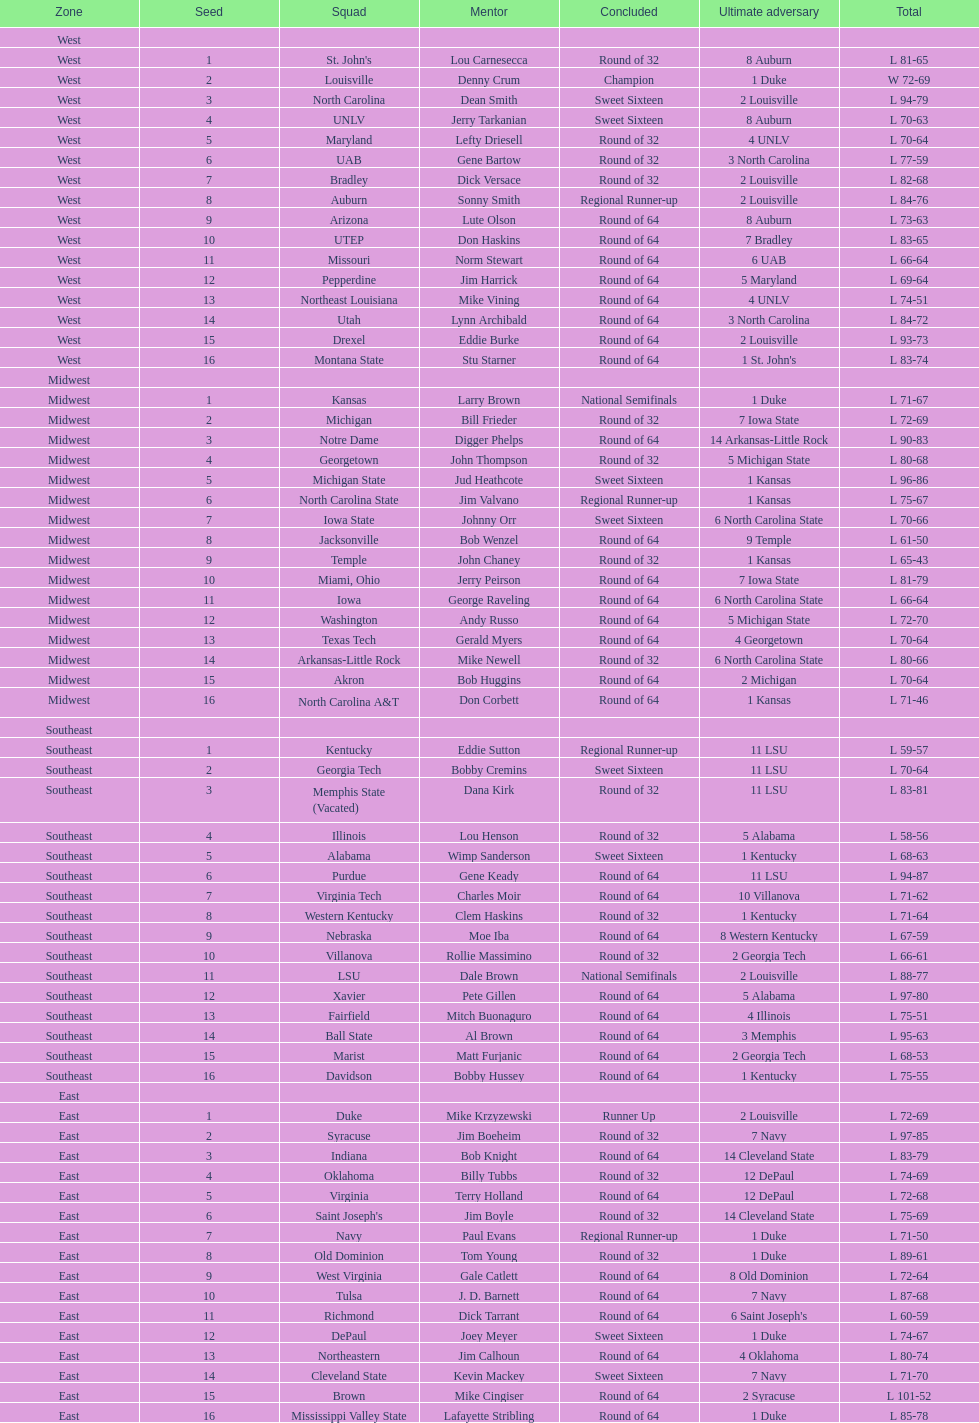Could you parse the entire table as a dict? {'header': ['Zone', 'Seed', 'Squad', 'Mentor', 'Concluded', 'Ultimate adversary', 'Total'], 'rows': [['West', '', '', '', '', '', ''], ['West', '1', "St. John's", 'Lou Carnesecca', 'Round of 32', '8 Auburn', 'L 81-65'], ['West', '2', 'Louisville', 'Denny Crum', 'Champion', '1 Duke', 'W 72-69'], ['West', '3', 'North Carolina', 'Dean Smith', 'Sweet Sixteen', '2 Louisville', 'L 94-79'], ['West', '4', 'UNLV', 'Jerry Tarkanian', 'Sweet Sixteen', '8 Auburn', 'L 70-63'], ['West', '5', 'Maryland', 'Lefty Driesell', 'Round of 32', '4 UNLV', 'L 70-64'], ['West', '6', 'UAB', 'Gene Bartow', 'Round of 32', '3 North Carolina', 'L 77-59'], ['West', '7', 'Bradley', 'Dick Versace', 'Round of 32', '2 Louisville', 'L 82-68'], ['West', '8', 'Auburn', 'Sonny Smith', 'Regional Runner-up', '2 Louisville', 'L 84-76'], ['West', '9', 'Arizona', 'Lute Olson', 'Round of 64', '8 Auburn', 'L 73-63'], ['West', '10', 'UTEP', 'Don Haskins', 'Round of 64', '7 Bradley', 'L 83-65'], ['West', '11', 'Missouri', 'Norm Stewart', 'Round of 64', '6 UAB', 'L 66-64'], ['West', '12', 'Pepperdine', 'Jim Harrick', 'Round of 64', '5 Maryland', 'L 69-64'], ['West', '13', 'Northeast Louisiana', 'Mike Vining', 'Round of 64', '4 UNLV', 'L 74-51'], ['West', '14', 'Utah', 'Lynn Archibald', 'Round of 64', '3 North Carolina', 'L 84-72'], ['West', '15', 'Drexel', 'Eddie Burke', 'Round of 64', '2 Louisville', 'L 93-73'], ['West', '16', 'Montana State', 'Stu Starner', 'Round of 64', "1 St. John's", 'L 83-74'], ['Midwest', '', '', '', '', '', ''], ['Midwest', '1', 'Kansas', 'Larry Brown', 'National Semifinals', '1 Duke', 'L 71-67'], ['Midwest', '2', 'Michigan', 'Bill Frieder', 'Round of 32', '7 Iowa State', 'L 72-69'], ['Midwest', '3', 'Notre Dame', 'Digger Phelps', 'Round of 64', '14 Arkansas-Little Rock', 'L 90-83'], ['Midwest', '4', 'Georgetown', 'John Thompson', 'Round of 32', '5 Michigan State', 'L 80-68'], ['Midwest', '5', 'Michigan State', 'Jud Heathcote', 'Sweet Sixteen', '1 Kansas', 'L 96-86'], ['Midwest', '6', 'North Carolina State', 'Jim Valvano', 'Regional Runner-up', '1 Kansas', 'L 75-67'], ['Midwest', '7', 'Iowa State', 'Johnny Orr', 'Sweet Sixteen', '6 North Carolina State', 'L 70-66'], ['Midwest', '8', 'Jacksonville', 'Bob Wenzel', 'Round of 64', '9 Temple', 'L 61-50'], ['Midwest', '9', 'Temple', 'John Chaney', 'Round of 32', '1 Kansas', 'L 65-43'], ['Midwest', '10', 'Miami, Ohio', 'Jerry Peirson', 'Round of 64', '7 Iowa State', 'L 81-79'], ['Midwest', '11', 'Iowa', 'George Raveling', 'Round of 64', '6 North Carolina State', 'L 66-64'], ['Midwest', '12', 'Washington', 'Andy Russo', 'Round of 64', '5 Michigan State', 'L 72-70'], ['Midwest', '13', 'Texas Tech', 'Gerald Myers', 'Round of 64', '4 Georgetown', 'L 70-64'], ['Midwest', '14', 'Arkansas-Little Rock', 'Mike Newell', 'Round of 32', '6 North Carolina State', 'L 80-66'], ['Midwest', '15', 'Akron', 'Bob Huggins', 'Round of 64', '2 Michigan', 'L 70-64'], ['Midwest', '16', 'North Carolina A&T', 'Don Corbett', 'Round of 64', '1 Kansas', 'L 71-46'], ['Southeast', '', '', '', '', '', ''], ['Southeast', '1', 'Kentucky', 'Eddie Sutton', 'Regional Runner-up', '11 LSU', 'L 59-57'], ['Southeast', '2', 'Georgia Tech', 'Bobby Cremins', 'Sweet Sixteen', '11 LSU', 'L 70-64'], ['Southeast', '3', 'Memphis State (Vacated)', 'Dana Kirk', 'Round of 32', '11 LSU', 'L 83-81'], ['Southeast', '4', 'Illinois', 'Lou Henson', 'Round of 32', '5 Alabama', 'L 58-56'], ['Southeast', '5', 'Alabama', 'Wimp Sanderson', 'Sweet Sixteen', '1 Kentucky', 'L 68-63'], ['Southeast', '6', 'Purdue', 'Gene Keady', 'Round of 64', '11 LSU', 'L 94-87'], ['Southeast', '7', 'Virginia Tech', 'Charles Moir', 'Round of 64', '10 Villanova', 'L 71-62'], ['Southeast', '8', 'Western Kentucky', 'Clem Haskins', 'Round of 32', '1 Kentucky', 'L 71-64'], ['Southeast', '9', 'Nebraska', 'Moe Iba', 'Round of 64', '8 Western Kentucky', 'L 67-59'], ['Southeast', '10', 'Villanova', 'Rollie Massimino', 'Round of 32', '2 Georgia Tech', 'L 66-61'], ['Southeast', '11', 'LSU', 'Dale Brown', 'National Semifinals', '2 Louisville', 'L 88-77'], ['Southeast', '12', 'Xavier', 'Pete Gillen', 'Round of 64', '5 Alabama', 'L 97-80'], ['Southeast', '13', 'Fairfield', 'Mitch Buonaguro', 'Round of 64', '4 Illinois', 'L 75-51'], ['Southeast', '14', 'Ball State', 'Al Brown', 'Round of 64', '3 Memphis', 'L 95-63'], ['Southeast', '15', 'Marist', 'Matt Furjanic', 'Round of 64', '2 Georgia Tech', 'L 68-53'], ['Southeast', '16', 'Davidson', 'Bobby Hussey', 'Round of 64', '1 Kentucky', 'L 75-55'], ['East', '', '', '', '', '', ''], ['East', '1', 'Duke', 'Mike Krzyzewski', 'Runner Up', '2 Louisville', 'L 72-69'], ['East', '2', 'Syracuse', 'Jim Boeheim', 'Round of 32', '7 Navy', 'L 97-85'], ['East', '3', 'Indiana', 'Bob Knight', 'Round of 64', '14 Cleveland State', 'L 83-79'], ['East', '4', 'Oklahoma', 'Billy Tubbs', 'Round of 32', '12 DePaul', 'L 74-69'], ['East', '5', 'Virginia', 'Terry Holland', 'Round of 64', '12 DePaul', 'L 72-68'], ['East', '6', "Saint Joseph's", 'Jim Boyle', 'Round of 32', '14 Cleveland State', 'L 75-69'], ['East', '7', 'Navy', 'Paul Evans', 'Regional Runner-up', '1 Duke', 'L 71-50'], ['East', '8', 'Old Dominion', 'Tom Young', 'Round of 32', '1 Duke', 'L 89-61'], ['East', '9', 'West Virginia', 'Gale Catlett', 'Round of 64', '8 Old Dominion', 'L 72-64'], ['East', '10', 'Tulsa', 'J. D. Barnett', 'Round of 64', '7 Navy', 'L 87-68'], ['East', '11', 'Richmond', 'Dick Tarrant', 'Round of 64', "6 Saint Joseph's", 'L 60-59'], ['East', '12', 'DePaul', 'Joey Meyer', 'Sweet Sixteen', '1 Duke', 'L 74-67'], ['East', '13', 'Northeastern', 'Jim Calhoun', 'Round of 64', '4 Oklahoma', 'L 80-74'], ['East', '14', 'Cleveland State', 'Kevin Mackey', 'Sweet Sixteen', '7 Navy', 'L 71-70'], ['East', '15', 'Brown', 'Mike Cingiser', 'Round of 64', '2 Syracuse', 'L 101-52'], ['East', '16', 'Mississippi Valley State', 'Lafayette Stribling', 'Round of 64', '1 Duke', 'L 85-78']]} North carolina and unlv each made it to which round? Sweet Sixteen. 